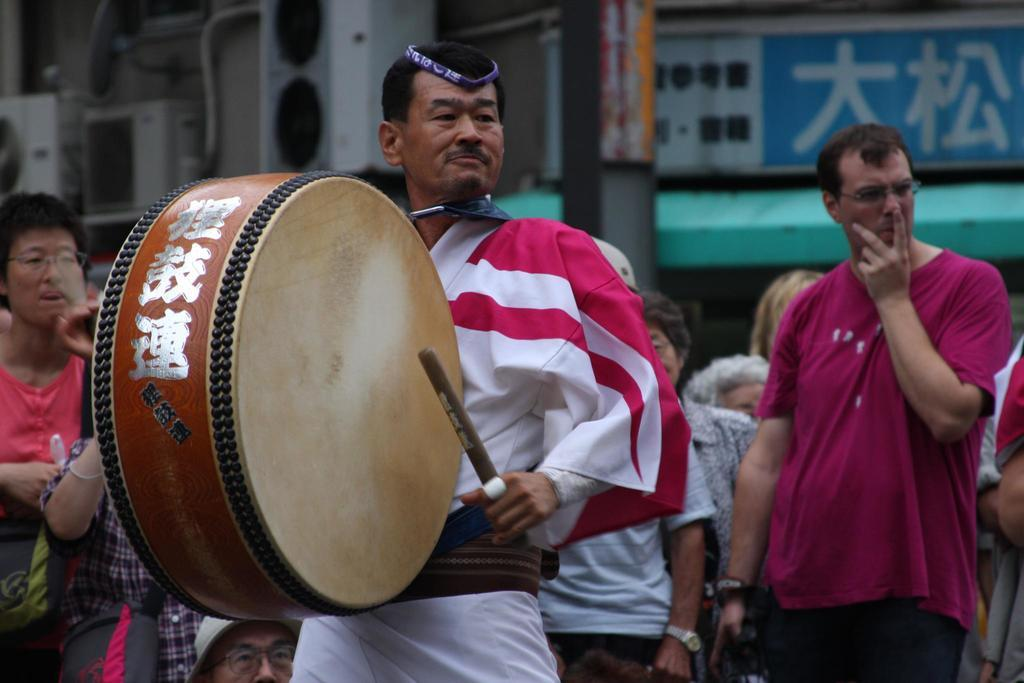What can be seen in the background of the image? There is a hoarding and a pole in the background of the image. What is the man in the image doing? The man is playing drums. What is the man holding in his hand? The man is holding a stick in his hand. What is the position of the persons in the image? All the persons in the image are standing. Can you describe the waves in the image? There are no waves present in the image. What type of pear is being used as a drumstick in the image? There is no pear being used as a drumstick in the image; the man is holding a stick. 